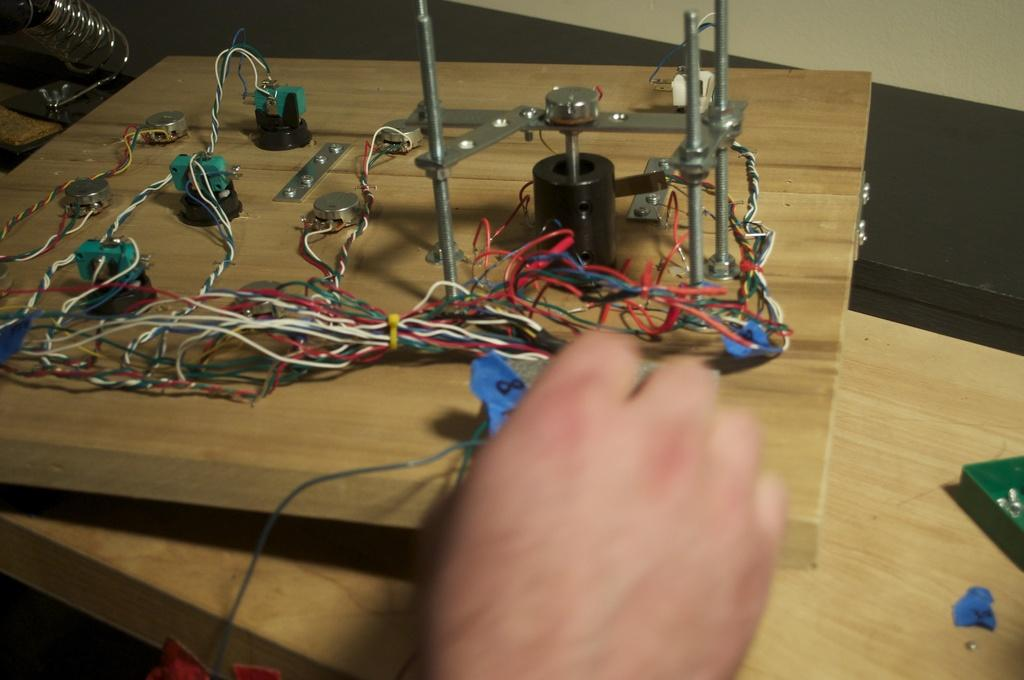What is the main subject of the image? There is a person in the image. What is the person holding in the image? The person is holding an electrical board. What color is the person's tongue in the image? There is no information about the person's tongue in the image, so we cannot determine its color. 